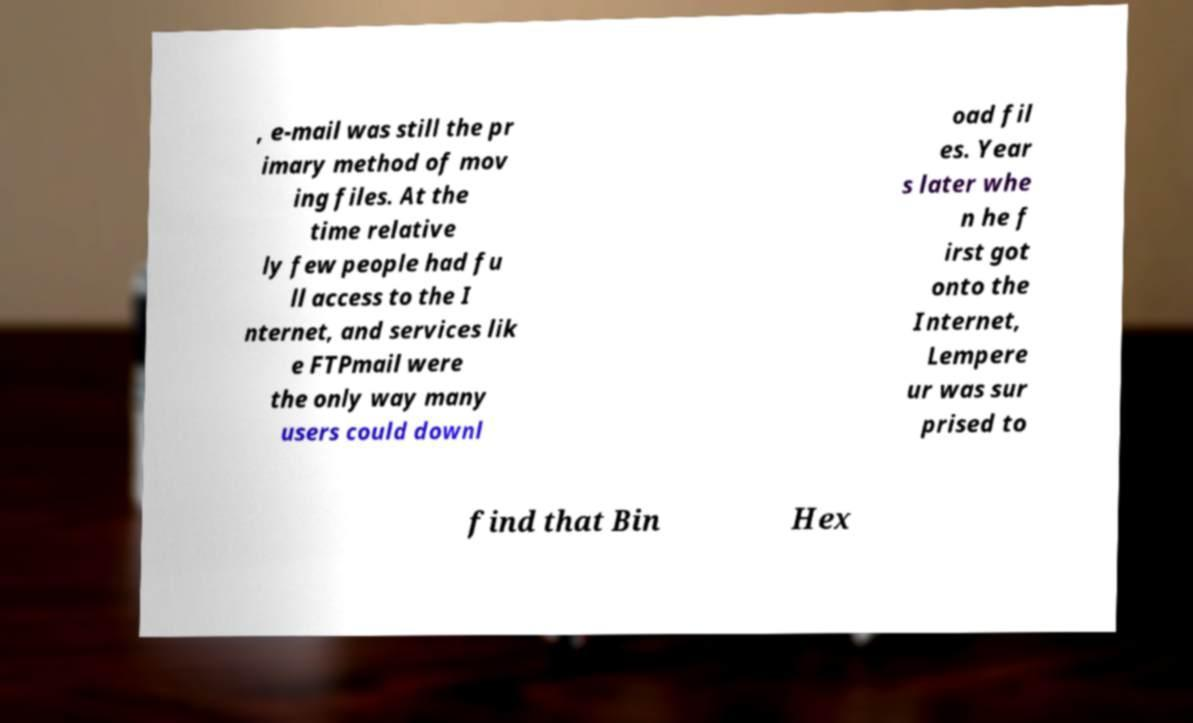What messages or text are displayed in this image? I need them in a readable, typed format. , e-mail was still the pr imary method of mov ing files. At the time relative ly few people had fu ll access to the I nternet, and services lik e FTPmail were the only way many users could downl oad fil es. Year s later whe n he f irst got onto the Internet, Lempere ur was sur prised to find that Bin Hex 